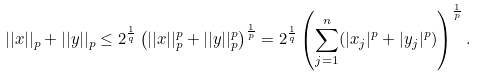Convert formula to latex. <formula><loc_0><loc_0><loc_500><loc_500>| | x | | _ { p } + | | y | | _ { p } \leq 2 ^ { \frac { 1 } { q } } \left ( | | x | | ^ { p } _ { p } + | | y | | ^ { p } _ { p } \right ) ^ { \frac { 1 } { p } } = 2 ^ { \frac { 1 } { q } } \left ( \sum _ { j = 1 } ^ { n } ( | x _ { j } | ^ { p } + | y _ { j } | ^ { p } ) \right ) ^ { \frac { 1 } { p } } .</formula> 